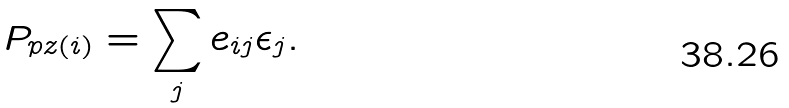Convert formula to latex. <formula><loc_0><loc_0><loc_500><loc_500>P _ { { p z } ( i ) } = \sum _ { j } { e _ { i j } } \epsilon _ { j } .</formula> 